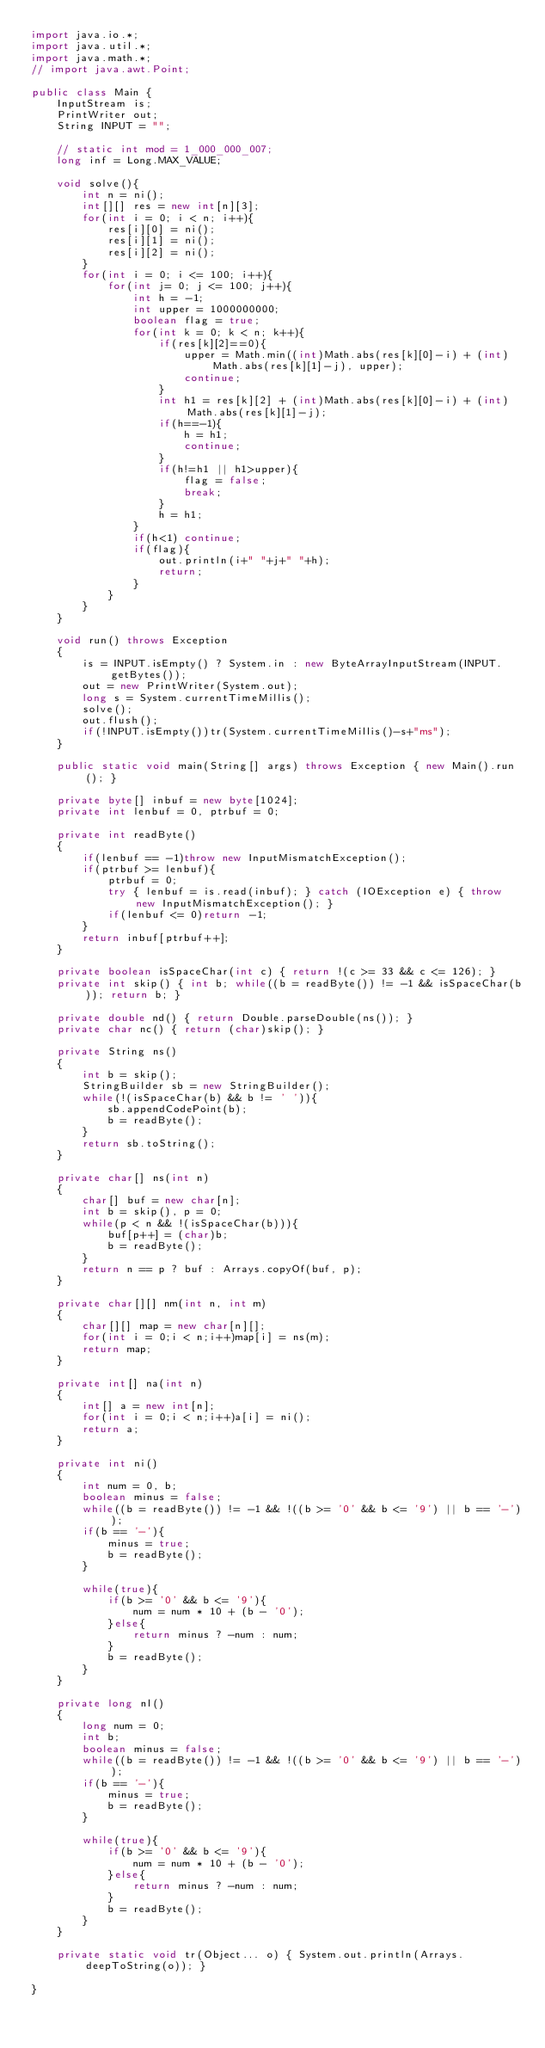<code> <loc_0><loc_0><loc_500><loc_500><_Java_>import java.io.*;
import java.util.*;
import java.math.*;
// import java.awt.Point;
 
public class Main {
    InputStream is;
    PrintWriter out;
    String INPUT = "";
 
    // static int mod = 1_000_000_007;
    long inf = Long.MAX_VALUE;

    void solve(){ 
        int n = ni();
        int[][] res = new int[n][3];
        for(int i = 0; i < n; i++){
            res[i][0] = ni();
            res[i][1] = ni();
            res[i][2] = ni();
        }
        for(int i = 0; i <= 100; i++){
            for(int j= 0; j <= 100; j++){
                int h = -1;
                int upper = 1000000000;
                boolean flag = true;
                for(int k = 0; k < n; k++){
                    if(res[k][2]==0){
                        upper = Math.min((int)Math.abs(res[k][0]-i) + (int)Math.abs(res[k][1]-j), upper);
                        continue;
                    }
                    int h1 = res[k][2] + (int)Math.abs(res[k][0]-i) + (int)Math.abs(res[k][1]-j);
                    if(h==-1){
                        h = h1;
                        continue;
                    }
                    if(h!=h1 || h1>upper){
                        flag = false;
                        break;
                    }
                    h = h1;
                }
                if(h<1) continue;
                if(flag){
                    out.println(i+" "+j+" "+h);
                    return;
                }
            }
        }
    }

    void run() throws Exception
    {
        is = INPUT.isEmpty() ? System.in : new ByteArrayInputStream(INPUT.getBytes());
        out = new PrintWriter(System.out);
        long s = System.currentTimeMillis();
        solve();
        out.flush();
        if(!INPUT.isEmpty())tr(System.currentTimeMillis()-s+"ms");
    }
    
    public static void main(String[] args) throws Exception { new Main().run(); }
    
    private byte[] inbuf = new byte[1024];
    private int lenbuf = 0, ptrbuf = 0;
    
    private int readByte()
    {
        if(lenbuf == -1)throw new InputMismatchException();
        if(ptrbuf >= lenbuf){
            ptrbuf = 0;
            try { lenbuf = is.read(inbuf); } catch (IOException e) { throw new InputMismatchException(); }
            if(lenbuf <= 0)return -1;
        }
        return inbuf[ptrbuf++];
    }
    
    private boolean isSpaceChar(int c) { return !(c >= 33 && c <= 126); }
    private int skip() { int b; while((b = readByte()) != -1 && isSpaceChar(b)); return b; }
    
    private double nd() { return Double.parseDouble(ns()); }
    private char nc() { return (char)skip(); }
    
    private String ns()
    {
        int b = skip();
        StringBuilder sb = new StringBuilder();
        while(!(isSpaceChar(b) && b != ' ')){
            sb.appendCodePoint(b);
            b = readByte();
        }
        return sb.toString();
    }
    
    private char[] ns(int n)
    {
        char[] buf = new char[n];
        int b = skip(), p = 0;
        while(p < n && !(isSpaceChar(b))){
            buf[p++] = (char)b;
            b = readByte();
        }
        return n == p ? buf : Arrays.copyOf(buf, p);
    }
    
    private char[][] nm(int n, int m)
    {
        char[][] map = new char[n][];
        for(int i = 0;i < n;i++)map[i] = ns(m);
        return map;
    }
    
    private int[] na(int n)
    {
        int[] a = new int[n];
        for(int i = 0;i < n;i++)a[i] = ni();
        return a;
    }
    
    private int ni()
    {
        int num = 0, b;
        boolean minus = false;
        while((b = readByte()) != -1 && !((b >= '0' && b <= '9') || b == '-'));
        if(b == '-'){
            minus = true;
            b = readByte();
        }
        
        while(true){
            if(b >= '0' && b <= '9'){
                num = num * 10 + (b - '0');
            }else{
                return minus ? -num : num;
            }
            b = readByte();
        }
    }
    
    private long nl()
    {
        long num = 0;
        int b;
        boolean minus = false;
        while((b = readByte()) != -1 && !((b >= '0' && b <= '9') || b == '-'));
        if(b == '-'){
            minus = true;
            b = readByte();
        }
        
        while(true){
            if(b >= '0' && b <= '9'){
                num = num * 10 + (b - '0');
            }else{
                return minus ? -num : num;
            }
            b = readByte();
        }
    }
    
    private static void tr(Object... o) { System.out.println(Arrays.deepToString(o)); }
 
}
</code> 